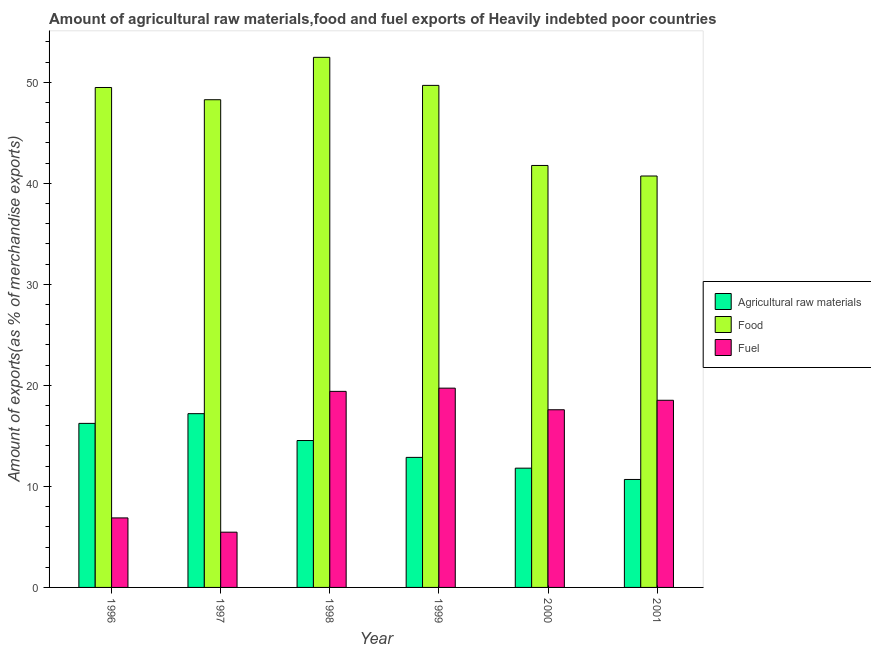How many bars are there on the 6th tick from the right?
Provide a short and direct response. 3. In how many cases, is the number of bars for a given year not equal to the number of legend labels?
Offer a very short reply. 0. What is the percentage of food exports in 1996?
Offer a very short reply. 49.49. Across all years, what is the maximum percentage of raw materials exports?
Give a very brief answer. 17.2. Across all years, what is the minimum percentage of raw materials exports?
Offer a terse response. 10.69. In which year was the percentage of fuel exports maximum?
Provide a succinct answer. 1999. In which year was the percentage of fuel exports minimum?
Your response must be concise. 1997. What is the total percentage of fuel exports in the graph?
Give a very brief answer. 87.6. What is the difference between the percentage of fuel exports in 1996 and that in 2000?
Give a very brief answer. -10.71. What is the difference between the percentage of raw materials exports in 1996 and the percentage of fuel exports in 2000?
Your response must be concise. 4.43. What is the average percentage of food exports per year?
Provide a short and direct response. 47.07. In the year 2000, what is the difference between the percentage of food exports and percentage of fuel exports?
Provide a succinct answer. 0. In how many years, is the percentage of food exports greater than 46 %?
Your answer should be compact. 4. What is the ratio of the percentage of fuel exports in 1996 to that in 1999?
Give a very brief answer. 0.35. Is the percentage of food exports in 1999 less than that in 2001?
Offer a terse response. No. Is the difference between the percentage of fuel exports in 2000 and 2001 greater than the difference between the percentage of raw materials exports in 2000 and 2001?
Keep it short and to the point. No. What is the difference between the highest and the second highest percentage of raw materials exports?
Provide a short and direct response. 0.96. What is the difference between the highest and the lowest percentage of food exports?
Provide a succinct answer. 11.75. In how many years, is the percentage of raw materials exports greater than the average percentage of raw materials exports taken over all years?
Offer a very short reply. 3. What does the 1st bar from the left in 2001 represents?
Provide a succinct answer. Agricultural raw materials. What does the 2nd bar from the right in 1998 represents?
Your answer should be compact. Food. Is it the case that in every year, the sum of the percentage of raw materials exports and percentage of food exports is greater than the percentage of fuel exports?
Provide a short and direct response. Yes. Are all the bars in the graph horizontal?
Provide a succinct answer. No. How many years are there in the graph?
Provide a succinct answer. 6. Where does the legend appear in the graph?
Keep it short and to the point. Center right. How many legend labels are there?
Your answer should be very brief. 3. How are the legend labels stacked?
Your answer should be very brief. Vertical. What is the title of the graph?
Offer a very short reply. Amount of agricultural raw materials,food and fuel exports of Heavily indebted poor countries. What is the label or title of the X-axis?
Your answer should be very brief. Year. What is the label or title of the Y-axis?
Offer a terse response. Amount of exports(as % of merchandise exports). What is the Amount of exports(as % of merchandise exports) of Agricultural raw materials in 1996?
Give a very brief answer. 16.24. What is the Amount of exports(as % of merchandise exports) of Food in 1996?
Provide a succinct answer. 49.49. What is the Amount of exports(as % of merchandise exports) in Fuel in 1996?
Keep it short and to the point. 6.88. What is the Amount of exports(as % of merchandise exports) of Agricultural raw materials in 1997?
Your answer should be very brief. 17.2. What is the Amount of exports(as % of merchandise exports) of Food in 1997?
Make the answer very short. 48.28. What is the Amount of exports(as % of merchandise exports) of Fuel in 1997?
Give a very brief answer. 5.47. What is the Amount of exports(as % of merchandise exports) of Agricultural raw materials in 1998?
Your response must be concise. 14.54. What is the Amount of exports(as % of merchandise exports) in Food in 1998?
Your answer should be very brief. 52.47. What is the Amount of exports(as % of merchandise exports) of Fuel in 1998?
Ensure brevity in your answer.  19.41. What is the Amount of exports(as % of merchandise exports) in Agricultural raw materials in 1999?
Keep it short and to the point. 12.87. What is the Amount of exports(as % of merchandise exports) of Food in 1999?
Offer a terse response. 49.69. What is the Amount of exports(as % of merchandise exports) of Fuel in 1999?
Your answer should be very brief. 19.73. What is the Amount of exports(as % of merchandise exports) of Agricultural raw materials in 2000?
Your answer should be compact. 11.81. What is the Amount of exports(as % of merchandise exports) of Food in 2000?
Keep it short and to the point. 41.77. What is the Amount of exports(as % of merchandise exports) in Fuel in 2000?
Provide a short and direct response. 17.59. What is the Amount of exports(as % of merchandise exports) of Agricultural raw materials in 2001?
Your answer should be compact. 10.69. What is the Amount of exports(as % of merchandise exports) in Food in 2001?
Keep it short and to the point. 40.72. What is the Amount of exports(as % of merchandise exports) in Fuel in 2001?
Provide a short and direct response. 18.52. Across all years, what is the maximum Amount of exports(as % of merchandise exports) of Agricultural raw materials?
Keep it short and to the point. 17.2. Across all years, what is the maximum Amount of exports(as % of merchandise exports) in Food?
Your response must be concise. 52.47. Across all years, what is the maximum Amount of exports(as % of merchandise exports) in Fuel?
Your answer should be very brief. 19.73. Across all years, what is the minimum Amount of exports(as % of merchandise exports) of Agricultural raw materials?
Your answer should be very brief. 10.69. Across all years, what is the minimum Amount of exports(as % of merchandise exports) of Food?
Offer a terse response. 40.72. Across all years, what is the minimum Amount of exports(as % of merchandise exports) of Fuel?
Your answer should be very brief. 5.47. What is the total Amount of exports(as % of merchandise exports) of Agricultural raw materials in the graph?
Make the answer very short. 83.34. What is the total Amount of exports(as % of merchandise exports) of Food in the graph?
Offer a very short reply. 282.42. What is the total Amount of exports(as % of merchandise exports) in Fuel in the graph?
Provide a short and direct response. 87.6. What is the difference between the Amount of exports(as % of merchandise exports) of Agricultural raw materials in 1996 and that in 1997?
Ensure brevity in your answer.  -0.96. What is the difference between the Amount of exports(as % of merchandise exports) in Food in 1996 and that in 1997?
Provide a succinct answer. 1.21. What is the difference between the Amount of exports(as % of merchandise exports) in Fuel in 1996 and that in 1997?
Your answer should be compact. 1.41. What is the difference between the Amount of exports(as % of merchandise exports) of Agricultural raw materials in 1996 and that in 1998?
Provide a succinct answer. 1.7. What is the difference between the Amount of exports(as % of merchandise exports) of Food in 1996 and that in 1998?
Make the answer very short. -2.99. What is the difference between the Amount of exports(as % of merchandise exports) in Fuel in 1996 and that in 1998?
Make the answer very short. -12.53. What is the difference between the Amount of exports(as % of merchandise exports) of Agricultural raw materials in 1996 and that in 1999?
Keep it short and to the point. 3.37. What is the difference between the Amount of exports(as % of merchandise exports) in Food in 1996 and that in 1999?
Offer a very short reply. -0.21. What is the difference between the Amount of exports(as % of merchandise exports) of Fuel in 1996 and that in 1999?
Ensure brevity in your answer.  -12.84. What is the difference between the Amount of exports(as % of merchandise exports) of Agricultural raw materials in 1996 and that in 2000?
Your answer should be very brief. 4.43. What is the difference between the Amount of exports(as % of merchandise exports) of Food in 1996 and that in 2000?
Make the answer very short. 7.72. What is the difference between the Amount of exports(as % of merchandise exports) in Fuel in 1996 and that in 2000?
Keep it short and to the point. -10.71. What is the difference between the Amount of exports(as % of merchandise exports) of Agricultural raw materials in 1996 and that in 2001?
Keep it short and to the point. 5.55. What is the difference between the Amount of exports(as % of merchandise exports) of Food in 1996 and that in 2001?
Provide a succinct answer. 8.76. What is the difference between the Amount of exports(as % of merchandise exports) of Fuel in 1996 and that in 2001?
Keep it short and to the point. -11.64. What is the difference between the Amount of exports(as % of merchandise exports) in Agricultural raw materials in 1997 and that in 1998?
Your response must be concise. 2.66. What is the difference between the Amount of exports(as % of merchandise exports) in Food in 1997 and that in 1998?
Make the answer very short. -4.2. What is the difference between the Amount of exports(as % of merchandise exports) of Fuel in 1997 and that in 1998?
Ensure brevity in your answer.  -13.94. What is the difference between the Amount of exports(as % of merchandise exports) in Agricultural raw materials in 1997 and that in 1999?
Your answer should be very brief. 4.33. What is the difference between the Amount of exports(as % of merchandise exports) of Food in 1997 and that in 1999?
Make the answer very short. -1.42. What is the difference between the Amount of exports(as % of merchandise exports) of Fuel in 1997 and that in 1999?
Offer a terse response. -14.26. What is the difference between the Amount of exports(as % of merchandise exports) in Agricultural raw materials in 1997 and that in 2000?
Provide a short and direct response. 5.39. What is the difference between the Amount of exports(as % of merchandise exports) in Food in 1997 and that in 2000?
Provide a succinct answer. 6.51. What is the difference between the Amount of exports(as % of merchandise exports) of Fuel in 1997 and that in 2000?
Provide a short and direct response. -12.12. What is the difference between the Amount of exports(as % of merchandise exports) in Agricultural raw materials in 1997 and that in 2001?
Offer a very short reply. 6.51. What is the difference between the Amount of exports(as % of merchandise exports) of Food in 1997 and that in 2001?
Keep it short and to the point. 7.55. What is the difference between the Amount of exports(as % of merchandise exports) of Fuel in 1997 and that in 2001?
Keep it short and to the point. -13.06. What is the difference between the Amount of exports(as % of merchandise exports) in Agricultural raw materials in 1998 and that in 1999?
Make the answer very short. 1.67. What is the difference between the Amount of exports(as % of merchandise exports) of Food in 1998 and that in 1999?
Your response must be concise. 2.78. What is the difference between the Amount of exports(as % of merchandise exports) in Fuel in 1998 and that in 1999?
Give a very brief answer. -0.32. What is the difference between the Amount of exports(as % of merchandise exports) of Agricultural raw materials in 1998 and that in 2000?
Give a very brief answer. 2.74. What is the difference between the Amount of exports(as % of merchandise exports) in Food in 1998 and that in 2000?
Offer a terse response. 10.7. What is the difference between the Amount of exports(as % of merchandise exports) in Fuel in 1998 and that in 2000?
Your answer should be very brief. 1.82. What is the difference between the Amount of exports(as % of merchandise exports) of Agricultural raw materials in 1998 and that in 2001?
Your answer should be very brief. 3.85. What is the difference between the Amount of exports(as % of merchandise exports) in Food in 1998 and that in 2001?
Make the answer very short. 11.75. What is the difference between the Amount of exports(as % of merchandise exports) in Fuel in 1998 and that in 2001?
Provide a succinct answer. 0.88. What is the difference between the Amount of exports(as % of merchandise exports) of Agricultural raw materials in 1999 and that in 2000?
Offer a very short reply. 1.07. What is the difference between the Amount of exports(as % of merchandise exports) of Food in 1999 and that in 2000?
Your response must be concise. 7.93. What is the difference between the Amount of exports(as % of merchandise exports) in Fuel in 1999 and that in 2000?
Your answer should be compact. 2.14. What is the difference between the Amount of exports(as % of merchandise exports) in Agricultural raw materials in 1999 and that in 2001?
Provide a short and direct response. 2.19. What is the difference between the Amount of exports(as % of merchandise exports) of Food in 1999 and that in 2001?
Keep it short and to the point. 8.97. What is the difference between the Amount of exports(as % of merchandise exports) in Fuel in 1999 and that in 2001?
Give a very brief answer. 1.2. What is the difference between the Amount of exports(as % of merchandise exports) in Agricultural raw materials in 2000 and that in 2001?
Keep it short and to the point. 1.12. What is the difference between the Amount of exports(as % of merchandise exports) in Food in 2000 and that in 2001?
Ensure brevity in your answer.  1.04. What is the difference between the Amount of exports(as % of merchandise exports) of Fuel in 2000 and that in 2001?
Make the answer very short. -0.94. What is the difference between the Amount of exports(as % of merchandise exports) of Agricultural raw materials in 1996 and the Amount of exports(as % of merchandise exports) of Food in 1997?
Keep it short and to the point. -32.04. What is the difference between the Amount of exports(as % of merchandise exports) in Agricultural raw materials in 1996 and the Amount of exports(as % of merchandise exports) in Fuel in 1997?
Ensure brevity in your answer.  10.77. What is the difference between the Amount of exports(as % of merchandise exports) of Food in 1996 and the Amount of exports(as % of merchandise exports) of Fuel in 1997?
Offer a very short reply. 44.02. What is the difference between the Amount of exports(as % of merchandise exports) of Agricultural raw materials in 1996 and the Amount of exports(as % of merchandise exports) of Food in 1998?
Provide a succinct answer. -36.23. What is the difference between the Amount of exports(as % of merchandise exports) in Agricultural raw materials in 1996 and the Amount of exports(as % of merchandise exports) in Fuel in 1998?
Provide a short and direct response. -3.17. What is the difference between the Amount of exports(as % of merchandise exports) in Food in 1996 and the Amount of exports(as % of merchandise exports) in Fuel in 1998?
Make the answer very short. 30.08. What is the difference between the Amount of exports(as % of merchandise exports) of Agricultural raw materials in 1996 and the Amount of exports(as % of merchandise exports) of Food in 1999?
Offer a terse response. -33.46. What is the difference between the Amount of exports(as % of merchandise exports) in Agricultural raw materials in 1996 and the Amount of exports(as % of merchandise exports) in Fuel in 1999?
Ensure brevity in your answer.  -3.49. What is the difference between the Amount of exports(as % of merchandise exports) in Food in 1996 and the Amount of exports(as % of merchandise exports) in Fuel in 1999?
Your answer should be compact. 29.76. What is the difference between the Amount of exports(as % of merchandise exports) in Agricultural raw materials in 1996 and the Amount of exports(as % of merchandise exports) in Food in 2000?
Provide a short and direct response. -25.53. What is the difference between the Amount of exports(as % of merchandise exports) in Agricultural raw materials in 1996 and the Amount of exports(as % of merchandise exports) in Fuel in 2000?
Offer a terse response. -1.35. What is the difference between the Amount of exports(as % of merchandise exports) in Food in 1996 and the Amount of exports(as % of merchandise exports) in Fuel in 2000?
Provide a short and direct response. 31.9. What is the difference between the Amount of exports(as % of merchandise exports) in Agricultural raw materials in 1996 and the Amount of exports(as % of merchandise exports) in Food in 2001?
Your response must be concise. -24.49. What is the difference between the Amount of exports(as % of merchandise exports) in Agricultural raw materials in 1996 and the Amount of exports(as % of merchandise exports) in Fuel in 2001?
Offer a terse response. -2.29. What is the difference between the Amount of exports(as % of merchandise exports) of Food in 1996 and the Amount of exports(as % of merchandise exports) of Fuel in 2001?
Ensure brevity in your answer.  30.96. What is the difference between the Amount of exports(as % of merchandise exports) of Agricultural raw materials in 1997 and the Amount of exports(as % of merchandise exports) of Food in 1998?
Offer a terse response. -35.27. What is the difference between the Amount of exports(as % of merchandise exports) of Agricultural raw materials in 1997 and the Amount of exports(as % of merchandise exports) of Fuel in 1998?
Ensure brevity in your answer.  -2.21. What is the difference between the Amount of exports(as % of merchandise exports) in Food in 1997 and the Amount of exports(as % of merchandise exports) in Fuel in 1998?
Give a very brief answer. 28.87. What is the difference between the Amount of exports(as % of merchandise exports) in Agricultural raw materials in 1997 and the Amount of exports(as % of merchandise exports) in Food in 1999?
Your answer should be very brief. -32.49. What is the difference between the Amount of exports(as % of merchandise exports) in Agricultural raw materials in 1997 and the Amount of exports(as % of merchandise exports) in Fuel in 1999?
Keep it short and to the point. -2.53. What is the difference between the Amount of exports(as % of merchandise exports) of Food in 1997 and the Amount of exports(as % of merchandise exports) of Fuel in 1999?
Ensure brevity in your answer.  28.55. What is the difference between the Amount of exports(as % of merchandise exports) in Agricultural raw materials in 1997 and the Amount of exports(as % of merchandise exports) in Food in 2000?
Give a very brief answer. -24.57. What is the difference between the Amount of exports(as % of merchandise exports) of Agricultural raw materials in 1997 and the Amount of exports(as % of merchandise exports) of Fuel in 2000?
Provide a short and direct response. -0.39. What is the difference between the Amount of exports(as % of merchandise exports) of Food in 1997 and the Amount of exports(as % of merchandise exports) of Fuel in 2000?
Provide a short and direct response. 30.69. What is the difference between the Amount of exports(as % of merchandise exports) in Agricultural raw materials in 1997 and the Amount of exports(as % of merchandise exports) in Food in 2001?
Offer a terse response. -23.52. What is the difference between the Amount of exports(as % of merchandise exports) in Agricultural raw materials in 1997 and the Amount of exports(as % of merchandise exports) in Fuel in 2001?
Your response must be concise. -1.33. What is the difference between the Amount of exports(as % of merchandise exports) of Food in 1997 and the Amount of exports(as % of merchandise exports) of Fuel in 2001?
Keep it short and to the point. 29.75. What is the difference between the Amount of exports(as % of merchandise exports) in Agricultural raw materials in 1998 and the Amount of exports(as % of merchandise exports) in Food in 1999?
Offer a terse response. -35.15. What is the difference between the Amount of exports(as % of merchandise exports) of Agricultural raw materials in 1998 and the Amount of exports(as % of merchandise exports) of Fuel in 1999?
Ensure brevity in your answer.  -5.19. What is the difference between the Amount of exports(as % of merchandise exports) of Food in 1998 and the Amount of exports(as % of merchandise exports) of Fuel in 1999?
Provide a succinct answer. 32.75. What is the difference between the Amount of exports(as % of merchandise exports) in Agricultural raw materials in 1998 and the Amount of exports(as % of merchandise exports) in Food in 2000?
Offer a terse response. -27.23. What is the difference between the Amount of exports(as % of merchandise exports) of Agricultural raw materials in 1998 and the Amount of exports(as % of merchandise exports) of Fuel in 2000?
Provide a succinct answer. -3.05. What is the difference between the Amount of exports(as % of merchandise exports) in Food in 1998 and the Amount of exports(as % of merchandise exports) in Fuel in 2000?
Offer a terse response. 34.88. What is the difference between the Amount of exports(as % of merchandise exports) in Agricultural raw materials in 1998 and the Amount of exports(as % of merchandise exports) in Food in 2001?
Offer a terse response. -26.18. What is the difference between the Amount of exports(as % of merchandise exports) in Agricultural raw materials in 1998 and the Amount of exports(as % of merchandise exports) in Fuel in 2001?
Offer a very short reply. -3.98. What is the difference between the Amount of exports(as % of merchandise exports) of Food in 1998 and the Amount of exports(as % of merchandise exports) of Fuel in 2001?
Give a very brief answer. 33.95. What is the difference between the Amount of exports(as % of merchandise exports) of Agricultural raw materials in 1999 and the Amount of exports(as % of merchandise exports) of Food in 2000?
Provide a succinct answer. -28.9. What is the difference between the Amount of exports(as % of merchandise exports) of Agricultural raw materials in 1999 and the Amount of exports(as % of merchandise exports) of Fuel in 2000?
Ensure brevity in your answer.  -4.72. What is the difference between the Amount of exports(as % of merchandise exports) in Food in 1999 and the Amount of exports(as % of merchandise exports) in Fuel in 2000?
Your answer should be very brief. 32.11. What is the difference between the Amount of exports(as % of merchandise exports) in Agricultural raw materials in 1999 and the Amount of exports(as % of merchandise exports) in Food in 2001?
Your answer should be very brief. -27.85. What is the difference between the Amount of exports(as % of merchandise exports) in Agricultural raw materials in 1999 and the Amount of exports(as % of merchandise exports) in Fuel in 2001?
Make the answer very short. -5.65. What is the difference between the Amount of exports(as % of merchandise exports) of Food in 1999 and the Amount of exports(as % of merchandise exports) of Fuel in 2001?
Your response must be concise. 31.17. What is the difference between the Amount of exports(as % of merchandise exports) of Agricultural raw materials in 2000 and the Amount of exports(as % of merchandise exports) of Food in 2001?
Give a very brief answer. -28.92. What is the difference between the Amount of exports(as % of merchandise exports) of Agricultural raw materials in 2000 and the Amount of exports(as % of merchandise exports) of Fuel in 2001?
Ensure brevity in your answer.  -6.72. What is the difference between the Amount of exports(as % of merchandise exports) in Food in 2000 and the Amount of exports(as % of merchandise exports) in Fuel in 2001?
Offer a very short reply. 23.24. What is the average Amount of exports(as % of merchandise exports) of Agricultural raw materials per year?
Your response must be concise. 13.89. What is the average Amount of exports(as % of merchandise exports) of Food per year?
Provide a short and direct response. 47.07. What is the average Amount of exports(as % of merchandise exports) in Fuel per year?
Your answer should be very brief. 14.6. In the year 1996, what is the difference between the Amount of exports(as % of merchandise exports) of Agricultural raw materials and Amount of exports(as % of merchandise exports) of Food?
Your answer should be compact. -33.25. In the year 1996, what is the difference between the Amount of exports(as % of merchandise exports) in Agricultural raw materials and Amount of exports(as % of merchandise exports) in Fuel?
Your answer should be compact. 9.36. In the year 1996, what is the difference between the Amount of exports(as % of merchandise exports) in Food and Amount of exports(as % of merchandise exports) in Fuel?
Provide a succinct answer. 42.6. In the year 1997, what is the difference between the Amount of exports(as % of merchandise exports) in Agricultural raw materials and Amount of exports(as % of merchandise exports) in Food?
Your response must be concise. -31.08. In the year 1997, what is the difference between the Amount of exports(as % of merchandise exports) in Agricultural raw materials and Amount of exports(as % of merchandise exports) in Fuel?
Provide a short and direct response. 11.73. In the year 1997, what is the difference between the Amount of exports(as % of merchandise exports) of Food and Amount of exports(as % of merchandise exports) of Fuel?
Make the answer very short. 42.81. In the year 1998, what is the difference between the Amount of exports(as % of merchandise exports) of Agricultural raw materials and Amount of exports(as % of merchandise exports) of Food?
Ensure brevity in your answer.  -37.93. In the year 1998, what is the difference between the Amount of exports(as % of merchandise exports) of Agricultural raw materials and Amount of exports(as % of merchandise exports) of Fuel?
Your answer should be very brief. -4.87. In the year 1998, what is the difference between the Amount of exports(as % of merchandise exports) of Food and Amount of exports(as % of merchandise exports) of Fuel?
Keep it short and to the point. 33.06. In the year 1999, what is the difference between the Amount of exports(as % of merchandise exports) of Agricultural raw materials and Amount of exports(as % of merchandise exports) of Food?
Keep it short and to the point. -36.82. In the year 1999, what is the difference between the Amount of exports(as % of merchandise exports) of Agricultural raw materials and Amount of exports(as % of merchandise exports) of Fuel?
Make the answer very short. -6.85. In the year 1999, what is the difference between the Amount of exports(as % of merchandise exports) of Food and Amount of exports(as % of merchandise exports) of Fuel?
Provide a succinct answer. 29.97. In the year 2000, what is the difference between the Amount of exports(as % of merchandise exports) in Agricultural raw materials and Amount of exports(as % of merchandise exports) in Food?
Your answer should be very brief. -29.96. In the year 2000, what is the difference between the Amount of exports(as % of merchandise exports) of Agricultural raw materials and Amount of exports(as % of merchandise exports) of Fuel?
Keep it short and to the point. -5.78. In the year 2000, what is the difference between the Amount of exports(as % of merchandise exports) of Food and Amount of exports(as % of merchandise exports) of Fuel?
Keep it short and to the point. 24.18. In the year 2001, what is the difference between the Amount of exports(as % of merchandise exports) of Agricultural raw materials and Amount of exports(as % of merchandise exports) of Food?
Offer a very short reply. -30.04. In the year 2001, what is the difference between the Amount of exports(as % of merchandise exports) of Agricultural raw materials and Amount of exports(as % of merchandise exports) of Fuel?
Give a very brief answer. -7.84. In the year 2001, what is the difference between the Amount of exports(as % of merchandise exports) in Food and Amount of exports(as % of merchandise exports) in Fuel?
Make the answer very short. 22.2. What is the ratio of the Amount of exports(as % of merchandise exports) of Agricultural raw materials in 1996 to that in 1997?
Your answer should be compact. 0.94. What is the ratio of the Amount of exports(as % of merchandise exports) in Food in 1996 to that in 1997?
Offer a terse response. 1.03. What is the ratio of the Amount of exports(as % of merchandise exports) of Fuel in 1996 to that in 1997?
Give a very brief answer. 1.26. What is the ratio of the Amount of exports(as % of merchandise exports) of Agricultural raw materials in 1996 to that in 1998?
Provide a succinct answer. 1.12. What is the ratio of the Amount of exports(as % of merchandise exports) in Food in 1996 to that in 1998?
Offer a very short reply. 0.94. What is the ratio of the Amount of exports(as % of merchandise exports) in Fuel in 1996 to that in 1998?
Your answer should be compact. 0.35. What is the ratio of the Amount of exports(as % of merchandise exports) in Agricultural raw materials in 1996 to that in 1999?
Make the answer very short. 1.26. What is the ratio of the Amount of exports(as % of merchandise exports) in Food in 1996 to that in 1999?
Make the answer very short. 1. What is the ratio of the Amount of exports(as % of merchandise exports) in Fuel in 1996 to that in 1999?
Ensure brevity in your answer.  0.35. What is the ratio of the Amount of exports(as % of merchandise exports) in Agricultural raw materials in 1996 to that in 2000?
Your answer should be very brief. 1.38. What is the ratio of the Amount of exports(as % of merchandise exports) in Food in 1996 to that in 2000?
Offer a very short reply. 1.18. What is the ratio of the Amount of exports(as % of merchandise exports) of Fuel in 1996 to that in 2000?
Your response must be concise. 0.39. What is the ratio of the Amount of exports(as % of merchandise exports) in Agricultural raw materials in 1996 to that in 2001?
Your answer should be very brief. 1.52. What is the ratio of the Amount of exports(as % of merchandise exports) of Food in 1996 to that in 2001?
Provide a succinct answer. 1.22. What is the ratio of the Amount of exports(as % of merchandise exports) in Fuel in 1996 to that in 2001?
Your response must be concise. 0.37. What is the ratio of the Amount of exports(as % of merchandise exports) in Agricultural raw materials in 1997 to that in 1998?
Provide a succinct answer. 1.18. What is the ratio of the Amount of exports(as % of merchandise exports) of Fuel in 1997 to that in 1998?
Make the answer very short. 0.28. What is the ratio of the Amount of exports(as % of merchandise exports) of Agricultural raw materials in 1997 to that in 1999?
Make the answer very short. 1.34. What is the ratio of the Amount of exports(as % of merchandise exports) in Food in 1997 to that in 1999?
Your answer should be compact. 0.97. What is the ratio of the Amount of exports(as % of merchandise exports) of Fuel in 1997 to that in 1999?
Offer a terse response. 0.28. What is the ratio of the Amount of exports(as % of merchandise exports) of Agricultural raw materials in 1997 to that in 2000?
Make the answer very short. 1.46. What is the ratio of the Amount of exports(as % of merchandise exports) of Food in 1997 to that in 2000?
Keep it short and to the point. 1.16. What is the ratio of the Amount of exports(as % of merchandise exports) of Fuel in 1997 to that in 2000?
Offer a terse response. 0.31. What is the ratio of the Amount of exports(as % of merchandise exports) of Agricultural raw materials in 1997 to that in 2001?
Give a very brief answer. 1.61. What is the ratio of the Amount of exports(as % of merchandise exports) in Food in 1997 to that in 2001?
Make the answer very short. 1.19. What is the ratio of the Amount of exports(as % of merchandise exports) in Fuel in 1997 to that in 2001?
Your response must be concise. 0.3. What is the ratio of the Amount of exports(as % of merchandise exports) of Agricultural raw materials in 1998 to that in 1999?
Keep it short and to the point. 1.13. What is the ratio of the Amount of exports(as % of merchandise exports) in Food in 1998 to that in 1999?
Keep it short and to the point. 1.06. What is the ratio of the Amount of exports(as % of merchandise exports) of Fuel in 1998 to that in 1999?
Your answer should be very brief. 0.98. What is the ratio of the Amount of exports(as % of merchandise exports) in Agricultural raw materials in 1998 to that in 2000?
Your response must be concise. 1.23. What is the ratio of the Amount of exports(as % of merchandise exports) of Food in 1998 to that in 2000?
Your response must be concise. 1.26. What is the ratio of the Amount of exports(as % of merchandise exports) in Fuel in 1998 to that in 2000?
Offer a terse response. 1.1. What is the ratio of the Amount of exports(as % of merchandise exports) in Agricultural raw materials in 1998 to that in 2001?
Your answer should be compact. 1.36. What is the ratio of the Amount of exports(as % of merchandise exports) in Food in 1998 to that in 2001?
Your answer should be compact. 1.29. What is the ratio of the Amount of exports(as % of merchandise exports) in Fuel in 1998 to that in 2001?
Offer a very short reply. 1.05. What is the ratio of the Amount of exports(as % of merchandise exports) in Agricultural raw materials in 1999 to that in 2000?
Offer a very short reply. 1.09. What is the ratio of the Amount of exports(as % of merchandise exports) of Food in 1999 to that in 2000?
Provide a succinct answer. 1.19. What is the ratio of the Amount of exports(as % of merchandise exports) of Fuel in 1999 to that in 2000?
Keep it short and to the point. 1.12. What is the ratio of the Amount of exports(as % of merchandise exports) of Agricultural raw materials in 1999 to that in 2001?
Provide a short and direct response. 1.2. What is the ratio of the Amount of exports(as % of merchandise exports) in Food in 1999 to that in 2001?
Ensure brevity in your answer.  1.22. What is the ratio of the Amount of exports(as % of merchandise exports) of Fuel in 1999 to that in 2001?
Provide a succinct answer. 1.06. What is the ratio of the Amount of exports(as % of merchandise exports) in Agricultural raw materials in 2000 to that in 2001?
Your answer should be very brief. 1.1. What is the ratio of the Amount of exports(as % of merchandise exports) of Food in 2000 to that in 2001?
Your answer should be very brief. 1.03. What is the ratio of the Amount of exports(as % of merchandise exports) in Fuel in 2000 to that in 2001?
Your answer should be very brief. 0.95. What is the difference between the highest and the second highest Amount of exports(as % of merchandise exports) of Agricultural raw materials?
Offer a very short reply. 0.96. What is the difference between the highest and the second highest Amount of exports(as % of merchandise exports) of Food?
Offer a terse response. 2.78. What is the difference between the highest and the second highest Amount of exports(as % of merchandise exports) of Fuel?
Your response must be concise. 0.32. What is the difference between the highest and the lowest Amount of exports(as % of merchandise exports) of Agricultural raw materials?
Offer a very short reply. 6.51. What is the difference between the highest and the lowest Amount of exports(as % of merchandise exports) in Food?
Your answer should be compact. 11.75. What is the difference between the highest and the lowest Amount of exports(as % of merchandise exports) in Fuel?
Offer a terse response. 14.26. 